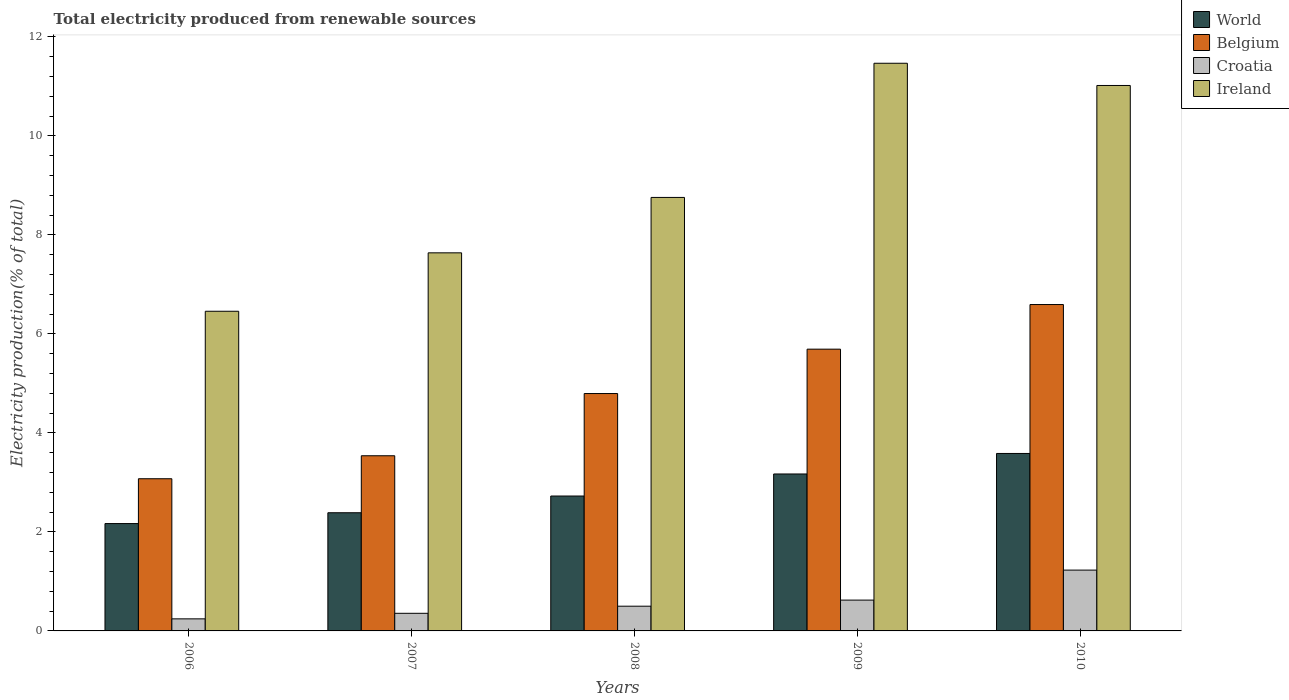How many groups of bars are there?
Your response must be concise. 5. Are the number of bars per tick equal to the number of legend labels?
Provide a short and direct response. Yes. How many bars are there on the 4th tick from the right?
Provide a short and direct response. 4. What is the label of the 2nd group of bars from the left?
Keep it short and to the point. 2007. What is the total electricity produced in Belgium in 2008?
Ensure brevity in your answer.  4.8. Across all years, what is the maximum total electricity produced in Belgium?
Ensure brevity in your answer.  6.59. Across all years, what is the minimum total electricity produced in World?
Your answer should be very brief. 2.17. What is the total total electricity produced in Ireland in the graph?
Your answer should be compact. 45.34. What is the difference between the total electricity produced in Belgium in 2008 and that in 2010?
Your response must be concise. -1.8. What is the difference between the total electricity produced in Belgium in 2008 and the total electricity produced in Ireland in 2006?
Keep it short and to the point. -1.66. What is the average total electricity produced in World per year?
Provide a succinct answer. 2.81. In the year 2009, what is the difference between the total electricity produced in Ireland and total electricity produced in Croatia?
Make the answer very short. 10.84. What is the ratio of the total electricity produced in Ireland in 2007 to that in 2010?
Provide a short and direct response. 0.69. Is the total electricity produced in Croatia in 2006 less than that in 2010?
Provide a short and direct response. Yes. What is the difference between the highest and the second highest total electricity produced in World?
Offer a very short reply. 0.41. What is the difference between the highest and the lowest total electricity produced in Belgium?
Offer a very short reply. 3.52. In how many years, is the total electricity produced in Belgium greater than the average total electricity produced in Belgium taken over all years?
Provide a succinct answer. 3. Is the sum of the total electricity produced in Ireland in 2007 and 2009 greater than the maximum total electricity produced in Belgium across all years?
Your answer should be very brief. Yes. Is it the case that in every year, the sum of the total electricity produced in Ireland and total electricity produced in Belgium is greater than the sum of total electricity produced in Croatia and total electricity produced in World?
Keep it short and to the point. Yes. What does the 1st bar from the right in 2009 represents?
Your answer should be compact. Ireland. How many bars are there?
Provide a succinct answer. 20. Are all the bars in the graph horizontal?
Ensure brevity in your answer.  No. Does the graph contain any zero values?
Provide a short and direct response. No. Does the graph contain grids?
Your response must be concise. No. How many legend labels are there?
Offer a very short reply. 4. How are the legend labels stacked?
Ensure brevity in your answer.  Vertical. What is the title of the graph?
Provide a short and direct response. Total electricity produced from renewable sources. Does "Slovak Republic" appear as one of the legend labels in the graph?
Give a very brief answer. No. What is the label or title of the X-axis?
Keep it short and to the point. Years. What is the Electricity production(% of total) in World in 2006?
Your answer should be compact. 2.17. What is the Electricity production(% of total) in Belgium in 2006?
Make the answer very short. 3.07. What is the Electricity production(% of total) of Croatia in 2006?
Offer a very short reply. 0.24. What is the Electricity production(% of total) in Ireland in 2006?
Make the answer very short. 6.46. What is the Electricity production(% of total) in World in 2007?
Keep it short and to the point. 2.39. What is the Electricity production(% of total) in Belgium in 2007?
Your answer should be compact. 3.54. What is the Electricity production(% of total) in Croatia in 2007?
Offer a terse response. 0.36. What is the Electricity production(% of total) in Ireland in 2007?
Give a very brief answer. 7.64. What is the Electricity production(% of total) of World in 2008?
Your answer should be compact. 2.72. What is the Electricity production(% of total) of Belgium in 2008?
Offer a terse response. 4.8. What is the Electricity production(% of total) in Croatia in 2008?
Provide a succinct answer. 0.5. What is the Electricity production(% of total) in Ireland in 2008?
Provide a short and direct response. 8.76. What is the Electricity production(% of total) of World in 2009?
Your answer should be very brief. 3.17. What is the Electricity production(% of total) in Belgium in 2009?
Provide a succinct answer. 5.69. What is the Electricity production(% of total) of Croatia in 2009?
Your response must be concise. 0.62. What is the Electricity production(% of total) of Ireland in 2009?
Your response must be concise. 11.47. What is the Electricity production(% of total) in World in 2010?
Provide a short and direct response. 3.58. What is the Electricity production(% of total) in Belgium in 2010?
Keep it short and to the point. 6.59. What is the Electricity production(% of total) of Croatia in 2010?
Keep it short and to the point. 1.23. What is the Electricity production(% of total) in Ireland in 2010?
Ensure brevity in your answer.  11.02. Across all years, what is the maximum Electricity production(% of total) of World?
Keep it short and to the point. 3.58. Across all years, what is the maximum Electricity production(% of total) of Belgium?
Offer a terse response. 6.59. Across all years, what is the maximum Electricity production(% of total) in Croatia?
Your response must be concise. 1.23. Across all years, what is the maximum Electricity production(% of total) of Ireland?
Offer a very short reply. 11.47. Across all years, what is the minimum Electricity production(% of total) of World?
Keep it short and to the point. 2.17. Across all years, what is the minimum Electricity production(% of total) of Belgium?
Your answer should be compact. 3.07. Across all years, what is the minimum Electricity production(% of total) of Croatia?
Offer a very short reply. 0.24. Across all years, what is the minimum Electricity production(% of total) in Ireland?
Your response must be concise. 6.46. What is the total Electricity production(% of total) of World in the graph?
Your answer should be very brief. 14.04. What is the total Electricity production(% of total) in Belgium in the graph?
Keep it short and to the point. 23.69. What is the total Electricity production(% of total) in Croatia in the graph?
Make the answer very short. 2.95. What is the total Electricity production(% of total) of Ireland in the graph?
Your answer should be very brief. 45.34. What is the difference between the Electricity production(% of total) in World in 2006 and that in 2007?
Provide a short and direct response. -0.22. What is the difference between the Electricity production(% of total) in Belgium in 2006 and that in 2007?
Keep it short and to the point. -0.46. What is the difference between the Electricity production(% of total) of Croatia in 2006 and that in 2007?
Your answer should be compact. -0.11. What is the difference between the Electricity production(% of total) of Ireland in 2006 and that in 2007?
Your answer should be compact. -1.18. What is the difference between the Electricity production(% of total) in World in 2006 and that in 2008?
Provide a succinct answer. -0.56. What is the difference between the Electricity production(% of total) in Belgium in 2006 and that in 2008?
Provide a short and direct response. -1.72. What is the difference between the Electricity production(% of total) in Croatia in 2006 and that in 2008?
Your response must be concise. -0.26. What is the difference between the Electricity production(% of total) in Ireland in 2006 and that in 2008?
Your response must be concise. -2.3. What is the difference between the Electricity production(% of total) in World in 2006 and that in 2009?
Ensure brevity in your answer.  -1. What is the difference between the Electricity production(% of total) of Belgium in 2006 and that in 2009?
Your response must be concise. -2.62. What is the difference between the Electricity production(% of total) in Croatia in 2006 and that in 2009?
Provide a short and direct response. -0.38. What is the difference between the Electricity production(% of total) in Ireland in 2006 and that in 2009?
Offer a very short reply. -5.01. What is the difference between the Electricity production(% of total) in World in 2006 and that in 2010?
Make the answer very short. -1.42. What is the difference between the Electricity production(% of total) in Belgium in 2006 and that in 2010?
Give a very brief answer. -3.52. What is the difference between the Electricity production(% of total) of Croatia in 2006 and that in 2010?
Ensure brevity in your answer.  -0.98. What is the difference between the Electricity production(% of total) in Ireland in 2006 and that in 2010?
Ensure brevity in your answer.  -4.56. What is the difference between the Electricity production(% of total) of World in 2007 and that in 2008?
Offer a very short reply. -0.34. What is the difference between the Electricity production(% of total) in Belgium in 2007 and that in 2008?
Keep it short and to the point. -1.26. What is the difference between the Electricity production(% of total) of Croatia in 2007 and that in 2008?
Offer a very short reply. -0.14. What is the difference between the Electricity production(% of total) of Ireland in 2007 and that in 2008?
Your response must be concise. -1.12. What is the difference between the Electricity production(% of total) of World in 2007 and that in 2009?
Offer a very short reply. -0.78. What is the difference between the Electricity production(% of total) of Belgium in 2007 and that in 2009?
Your response must be concise. -2.15. What is the difference between the Electricity production(% of total) of Croatia in 2007 and that in 2009?
Your response must be concise. -0.27. What is the difference between the Electricity production(% of total) in Ireland in 2007 and that in 2009?
Offer a very short reply. -3.83. What is the difference between the Electricity production(% of total) in World in 2007 and that in 2010?
Provide a succinct answer. -1.2. What is the difference between the Electricity production(% of total) of Belgium in 2007 and that in 2010?
Your answer should be very brief. -3.05. What is the difference between the Electricity production(% of total) in Croatia in 2007 and that in 2010?
Give a very brief answer. -0.87. What is the difference between the Electricity production(% of total) of Ireland in 2007 and that in 2010?
Provide a succinct answer. -3.38. What is the difference between the Electricity production(% of total) of World in 2008 and that in 2009?
Keep it short and to the point. -0.45. What is the difference between the Electricity production(% of total) in Belgium in 2008 and that in 2009?
Give a very brief answer. -0.9. What is the difference between the Electricity production(% of total) in Croatia in 2008 and that in 2009?
Offer a terse response. -0.12. What is the difference between the Electricity production(% of total) in Ireland in 2008 and that in 2009?
Provide a succinct answer. -2.71. What is the difference between the Electricity production(% of total) in World in 2008 and that in 2010?
Provide a succinct answer. -0.86. What is the difference between the Electricity production(% of total) in Belgium in 2008 and that in 2010?
Your answer should be very brief. -1.8. What is the difference between the Electricity production(% of total) of Croatia in 2008 and that in 2010?
Your response must be concise. -0.73. What is the difference between the Electricity production(% of total) of Ireland in 2008 and that in 2010?
Offer a terse response. -2.26. What is the difference between the Electricity production(% of total) of World in 2009 and that in 2010?
Your response must be concise. -0.41. What is the difference between the Electricity production(% of total) in Belgium in 2009 and that in 2010?
Keep it short and to the point. -0.9. What is the difference between the Electricity production(% of total) in Croatia in 2009 and that in 2010?
Keep it short and to the point. -0.61. What is the difference between the Electricity production(% of total) of Ireland in 2009 and that in 2010?
Offer a terse response. 0.45. What is the difference between the Electricity production(% of total) in World in 2006 and the Electricity production(% of total) in Belgium in 2007?
Your answer should be very brief. -1.37. What is the difference between the Electricity production(% of total) in World in 2006 and the Electricity production(% of total) in Croatia in 2007?
Give a very brief answer. 1.81. What is the difference between the Electricity production(% of total) of World in 2006 and the Electricity production(% of total) of Ireland in 2007?
Keep it short and to the point. -5.47. What is the difference between the Electricity production(% of total) of Belgium in 2006 and the Electricity production(% of total) of Croatia in 2007?
Give a very brief answer. 2.72. What is the difference between the Electricity production(% of total) of Belgium in 2006 and the Electricity production(% of total) of Ireland in 2007?
Your answer should be compact. -4.56. What is the difference between the Electricity production(% of total) in Croatia in 2006 and the Electricity production(% of total) in Ireland in 2007?
Your answer should be very brief. -7.39. What is the difference between the Electricity production(% of total) of World in 2006 and the Electricity production(% of total) of Belgium in 2008?
Give a very brief answer. -2.63. What is the difference between the Electricity production(% of total) of World in 2006 and the Electricity production(% of total) of Croatia in 2008?
Provide a succinct answer. 1.67. What is the difference between the Electricity production(% of total) in World in 2006 and the Electricity production(% of total) in Ireland in 2008?
Give a very brief answer. -6.59. What is the difference between the Electricity production(% of total) in Belgium in 2006 and the Electricity production(% of total) in Croatia in 2008?
Offer a very short reply. 2.57. What is the difference between the Electricity production(% of total) of Belgium in 2006 and the Electricity production(% of total) of Ireland in 2008?
Provide a short and direct response. -5.68. What is the difference between the Electricity production(% of total) of Croatia in 2006 and the Electricity production(% of total) of Ireland in 2008?
Give a very brief answer. -8.51. What is the difference between the Electricity production(% of total) in World in 2006 and the Electricity production(% of total) in Belgium in 2009?
Your response must be concise. -3.52. What is the difference between the Electricity production(% of total) in World in 2006 and the Electricity production(% of total) in Croatia in 2009?
Make the answer very short. 1.55. What is the difference between the Electricity production(% of total) of World in 2006 and the Electricity production(% of total) of Ireland in 2009?
Provide a short and direct response. -9.3. What is the difference between the Electricity production(% of total) of Belgium in 2006 and the Electricity production(% of total) of Croatia in 2009?
Make the answer very short. 2.45. What is the difference between the Electricity production(% of total) in Belgium in 2006 and the Electricity production(% of total) in Ireland in 2009?
Your response must be concise. -8.39. What is the difference between the Electricity production(% of total) of Croatia in 2006 and the Electricity production(% of total) of Ireland in 2009?
Provide a succinct answer. -11.22. What is the difference between the Electricity production(% of total) of World in 2006 and the Electricity production(% of total) of Belgium in 2010?
Offer a terse response. -4.42. What is the difference between the Electricity production(% of total) of World in 2006 and the Electricity production(% of total) of Croatia in 2010?
Provide a short and direct response. 0.94. What is the difference between the Electricity production(% of total) of World in 2006 and the Electricity production(% of total) of Ireland in 2010?
Ensure brevity in your answer.  -8.85. What is the difference between the Electricity production(% of total) of Belgium in 2006 and the Electricity production(% of total) of Croatia in 2010?
Your response must be concise. 1.85. What is the difference between the Electricity production(% of total) of Belgium in 2006 and the Electricity production(% of total) of Ireland in 2010?
Your response must be concise. -7.94. What is the difference between the Electricity production(% of total) in Croatia in 2006 and the Electricity production(% of total) in Ireland in 2010?
Your answer should be compact. -10.77. What is the difference between the Electricity production(% of total) in World in 2007 and the Electricity production(% of total) in Belgium in 2008?
Your answer should be very brief. -2.41. What is the difference between the Electricity production(% of total) in World in 2007 and the Electricity production(% of total) in Croatia in 2008?
Offer a very short reply. 1.89. What is the difference between the Electricity production(% of total) of World in 2007 and the Electricity production(% of total) of Ireland in 2008?
Give a very brief answer. -6.37. What is the difference between the Electricity production(% of total) of Belgium in 2007 and the Electricity production(% of total) of Croatia in 2008?
Your answer should be very brief. 3.04. What is the difference between the Electricity production(% of total) in Belgium in 2007 and the Electricity production(% of total) in Ireland in 2008?
Offer a very short reply. -5.22. What is the difference between the Electricity production(% of total) of Croatia in 2007 and the Electricity production(% of total) of Ireland in 2008?
Ensure brevity in your answer.  -8.4. What is the difference between the Electricity production(% of total) in World in 2007 and the Electricity production(% of total) in Belgium in 2009?
Your response must be concise. -3.3. What is the difference between the Electricity production(% of total) in World in 2007 and the Electricity production(% of total) in Croatia in 2009?
Offer a very short reply. 1.76. What is the difference between the Electricity production(% of total) in World in 2007 and the Electricity production(% of total) in Ireland in 2009?
Provide a succinct answer. -9.08. What is the difference between the Electricity production(% of total) of Belgium in 2007 and the Electricity production(% of total) of Croatia in 2009?
Offer a very short reply. 2.92. What is the difference between the Electricity production(% of total) in Belgium in 2007 and the Electricity production(% of total) in Ireland in 2009?
Ensure brevity in your answer.  -7.93. What is the difference between the Electricity production(% of total) in Croatia in 2007 and the Electricity production(% of total) in Ireland in 2009?
Offer a very short reply. -11.11. What is the difference between the Electricity production(% of total) of World in 2007 and the Electricity production(% of total) of Belgium in 2010?
Provide a succinct answer. -4.21. What is the difference between the Electricity production(% of total) of World in 2007 and the Electricity production(% of total) of Croatia in 2010?
Ensure brevity in your answer.  1.16. What is the difference between the Electricity production(% of total) of World in 2007 and the Electricity production(% of total) of Ireland in 2010?
Your response must be concise. -8.63. What is the difference between the Electricity production(% of total) of Belgium in 2007 and the Electricity production(% of total) of Croatia in 2010?
Ensure brevity in your answer.  2.31. What is the difference between the Electricity production(% of total) in Belgium in 2007 and the Electricity production(% of total) in Ireland in 2010?
Ensure brevity in your answer.  -7.48. What is the difference between the Electricity production(% of total) of Croatia in 2007 and the Electricity production(% of total) of Ireland in 2010?
Provide a short and direct response. -10.66. What is the difference between the Electricity production(% of total) in World in 2008 and the Electricity production(% of total) in Belgium in 2009?
Offer a very short reply. -2.97. What is the difference between the Electricity production(% of total) in World in 2008 and the Electricity production(% of total) in Croatia in 2009?
Give a very brief answer. 2.1. What is the difference between the Electricity production(% of total) of World in 2008 and the Electricity production(% of total) of Ireland in 2009?
Keep it short and to the point. -8.74. What is the difference between the Electricity production(% of total) of Belgium in 2008 and the Electricity production(% of total) of Croatia in 2009?
Provide a short and direct response. 4.17. What is the difference between the Electricity production(% of total) in Belgium in 2008 and the Electricity production(% of total) in Ireland in 2009?
Your answer should be compact. -6.67. What is the difference between the Electricity production(% of total) in Croatia in 2008 and the Electricity production(% of total) in Ireland in 2009?
Provide a succinct answer. -10.97. What is the difference between the Electricity production(% of total) in World in 2008 and the Electricity production(% of total) in Belgium in 2010?
Your answer should be compact. -3.87. What is the difference between the Electricity production(% of total) in World in 2008 and the Electricity production(% of total) in Croatia in 2010?
Your response must be concise. 1.5. What is the difference between the Electricity production(% of total) in World in 2008 and the Electricity production(% of total) in Ireland in 2010?
Your answer should be very brief. -8.29. What is the difference between the Electricity production(% of total) in Belgium in 2008 and the Electricity production(% of total) in Croatia in 2010?
Your answer should be compact. 3.57. What is the difference between the Electricity production(% of total) of Belgium in 2008 and the Electricity production(% of total) of Ireland in 2010?
Provide a short and direct response. -6.22. What is the difference between the Electricity production(% of total) in Croatia in 2008 and the Electricity production(% of total) in Ireland in 2010?
Keep it short and to the point. -10.52. What is the difference between the Electricity production(% of total) in World in 2009 and the Electricity production(% of total) in Belgium in 2010?
Your answer should be compact. -3.42. What is the difference between the Electricity production(% of total) in World in 2009 and the Electricity production(% of total) in Croatia in 2010?
Keep it short and to the point. 1.94. What is the difference between the Electricity production(% of total) of World in 2009 and the Electricity production(% of total) of Ireland in 2010?
Your response must be concise. -7.85. What is the difference between the Electricity production(% of total) of Belgium in 2009 and the Electricity production(% of total) of Croatia in 2010?
Give a very brief answer. 4.46. What is the difference between the Electricity production(% of total) of Belgium in 2009 and the Electricity production(% of total) of Ireland in 2010?
Offer a terse response. -5.33. What is the difference between the Electricity production(% of total) of Croatia in 2009 and the Electricity production(% of total) of Ireland in 2010?
Keep it short and to the point. -10.4. What is the average Electricity production(% of total) of World per year?
Offer a very short reply. 2.81. What is the average Electricity production(% of total) in Belgium per year?
Provide a succinct answer. 4.74. What is the average Electricity production(% of total) in Croatia per year?
Make the answer very short. 0.59. What is the average Electricity production(% of total) in Ireland per year?
Give a very brief answer. 9.07. In the year 2006, what is the difference between the Electricity production(% of total) of World and Electricity production(% of total) of Belgium?
Give a very brief answer. -0.91. In the year 2006, what is the difference between the Electricity production(% of total) of World and Electricity production(% of total) of Croatia?
Your answer should be compact. 1.92. In the year 2006, what is the difference between the Electricity production(% of total) of World and Electricity production(% of total) of Ireland?
Give a very brief answer. -4.29. In the year 2006, what is the difference between the Electricity production(% of total) of Belgium and Electricity production(% of total) of Croatia?
Your answer should be compact. 2.83. In the year 2006, what is the difference between the Electricity production(% of total) of Belgium and Electricity production(% of total) of Ireland?
Your response must be concise. -3.38. In the year 2006, what is the difference between the Electricity production(% of total) in Croatia and Electricity production(% of total) in Ireland?
Provide a succinct answer. -6.21. In the year 2007, what is the difference between the Electricity production(% of total) of World and Electricity production(% of total) of Belgium?
Keep it short and to the point. -1.15. In the year 2007, what is the difference between the Electricity production(% of total) in World and Electricity production(% of total) in Croatia?
Make the answer very short. 2.03. In the year 2007, what is the difference between the Electricity production(% of total) in World and Electricity production(% of total) in Ireland?
Make the answer very short. -5.25. In the year 2007, what is the difference between the Electricity production(% of total) in Belgium and Electricity production(% of total) in Croatia?
Your answer should be very brief. 3.18. In the year 2007, what is the difference between the Electricity production(% of total) in Belgium and Electricity production(% of total) in Ireland?
Your answer should be very brief. -4.1. In the year 2007, what is the difference between the Electricity production(% of total) of Croatia and Electricity production(% of total) of Ireland?
Offer a very short reply. -7.28. In the year 2008, what is the difference between the Electricity production(% of total) of World and Electricity production(% of total) of Belgium?
Ensure brevity in your answer.  -2.07. In the year 2008, what is the difference between the Electricity production(% of total) in World and Electricity production(% of total) in Croatia?
Keep it short and to the point. 2.23. In the year 2008, what is the difference between the Electricity production(% of total) of World and Electricity production(% of total) of Ireland?
Offer a very short reply. -6.03. In the year 2008, what is the difference between the Electricity production(% of total) in Belgium and Electricity production(% of total) in Croatia?
Give a very brief answer. 4.3. In the year 2008, what is the difference between the Electricity production(% of total) in Belgium and Electricity production(% of total) in Ireland?
Provide a succinct answer. -3.96. In the year 2008, what is the difference between the Electricity production(% of total) in Croatia and Electricity production(% of total) in Ireland?
Offer a very short reply. -8.26. In the year 2009, what is the difference between the Electricity production(% of total) in World and Electricity production(% of total) in Belgium?
Give a very brief answer. -2.52. In the year 2009, what is the difference between the Electricity production(% of total) of World and Electricity production(% of total) of Croatia?
Your response must be concise. 2.55. In the year 2009, what is the difference between the Electricity production(% of total) of World and Electricity production(% of total) of Ireland?
Offer a terse response. -8.3. In the year 2009, what is the difference between the Electricity production(% of total) in Belgium and Electricity production(% of total) in Croatia?
Provide a short and direct response. 5.07. In the year 2009, what is the difference between the Electricity production(% of total) in Belgium and Electricity production(% of total) in Ireland?
Give a very brief answer. -5.78. In the year 2009, what is the difference between the Electricity production(% of total) of Croatia and Electricity production(% of total) of Ireland?
Your answer should be compact. -10.84. In the year 2010, what is the difference between the Electricity production(% of total) of World and Electricity production(% of total) of Belgium?
Your answer should be very brief. -3.01. In the year 2010, what is the difference between the Electricity production(% of total) of World and Electricity production(% of total) of Croatia?
Ensure brevity in your answer.  2.36. In the year 2010, what is the difference between the Electricity production(% of total) in World and Electricity production(% of total) in Ireland?
Offer a terse response. -7.43. In the year 2010, what is the difference between the Electricity production(% of total) in Belgium and Electricity production(% of total) in Croatia?
Offer a terse response. 5.36. In the year 2010, what is the difference between the Electricity production(% of total) in Belgium and Electricity production(% of total) in Ireland?
Keep it short and to the point. -4.43. In the year 2010, what is the difference between the Electricity production(% of total) in Croatia and Electricity production(% of total) in Ireland?
Provide a short and direct response. -9.79. What is the ratio of the Electricity production(% of total) of World in 2006 to that in 2007?
Keep it short and to the point. 0.91. What is the ratio of the Electricity production(% of total) of Belgium in 2006 to that in 2007?
Give a very brief answer. 0.87. What is the ratio of the Electricity production(% of total) of Croatia in 2006 to that in 2007?
Provide a short and direct response. 0.68. What is the ratio of the Electricity production(% of total) of Ireland in 2006 to that in 2007?
Keep it short and to the point. 0.85. What is the ratio of the Electricity production(% of total) in World in 2006 to that in 2008?
Your answer should be compact. 0.8. What is the ratio of the Electricity production(% of total) in Belgium in 2006 to that in 2008?
Offer a very short reply. 0.64. What is the ratio of the Electricity production(% of total) of Croatia in 2006 to that in 2008?
Give a very brief answer. 0.49. What is the ratio of the Electricity production(% of total) of Ireland in 2006 to that in 2008?
Your answer should be very brief. 0.74. What is the ratio of the Electricity production(% of total) in World in 2006 to that in 2009?
Provide a succinct answer. 0.68. What is the ratio of the Electricity production(% of total) in Belgium in 2006 to that in 2009?
Provide a short and direct response. 0.54. What is the ratio of the Electricity production(% of total) of Croatia in 2006 to that in 2009?
Make the answer very short. 0.39. What is the ratio of the Electricity production(% of total) in Ireland in 2006 to that in 2009?
Provide a succinct answer. 0.56. What is the ratio of the Electricity production(% of total) of World in 2006 to that in 2010?
Offer a terse response. 0.6. What is the ratio of the Electricity production(% of total) of Belgium in 2006 to that in 2010?
Offer a terse response. 0.47. What is the ratio of the Electricity production(% of total) in Croatia in 2006 to that in 2010?
Your answer should be compact. 0.2. What is the ratio of the Electricity production(% of total) in Ireland in 2006 to that in 2010?
Offer a terse response. 0.59. What is the ratio of the Electricity production(% of total) of World in 2007 to that in 2008?
Your response must be concise. 0.88. What is the ratio of the Electricity production(% of total) of Belgium in 2007 to that in 2008?
Your answer should be very brief. 0.74. What is the ratio of the Electricity production(% of total) of Croatia in 2007 to that in 2008?
Your response must be concise. 0.71. What is the ratio of the Electricity production(% of total) of Ireland in 2007 to that in 2008?
Make the answer very short. 0.87. What is the ratio of the Electricity production(% of total) of World in 2007 to that in 2009?
Your answer should be very brief. 0.75. What is the ratio of the Electricity production(% of total) of Belgium in 2007 to that in 2009?
Offer a very short reply. 0.62. What is the ratio of the Electricity production(% of total) of Croatia in 2007 to that in 2009?
Your answer should be very brief. 0.57. What is the ratio of the Electricity production(% of total) in Ireland in 2007 to that in 2009?
Provide a succinct answer. 0.67. What is the ratio of the Electricity production(% of total) in World in 2007 to that in 2010?
Offer a very short reply. 0.67. What is the ratio of the Electricity production(% of total) in Belgium in 2007 to that in 2010?
Make the answer very short. 0.54. What is the ratio of the Electricity production(% of total) of Croatia in 2007 to that in 2010?
Offer a very short reply. 0.29. What is the ratio of the Electricity production(% of total) of Ireland in 2007 to that in 2010?
Offer a very short reply. 0.69. What is the ratio of the Electricity production(% of total) in World in 2008 to that in 2009?
Keep it short and to the point. 0.86. What is the ratio of the Electricity production(% of total) of Belgium in 2008 to that in 2009?
Your answer should be very brief. 0.84. What is the ratio of the Electricity production(% of total) of Croatia in 2008 to that in 2009?
Offer a terse response. 0.8. What is the ratio of the Electricity production(% of total) in Ireland in 2008 to that in 2009?
Give a very brief answer. 0.76. What is the ratio of the Electricity production(% of total) of World in 2008 to that in 2010?
Give a very brief answer. 0.76. What is the ratio of the Electricity production(% of total) in Belgium in 2008 to that in 2010?
Ensure brevity in your answer.  0.73. What is the ratio of the Electricity production(% of total) of Croatia in 2008 to that in 2010?
Ensure brevity in your answer.  0.41. What is the ratio of the Electricity production(% of total) in Ireland in 2008 to that in 2010?
Offer a very short reply. 0.79. What is the ratio of the Electricity production(% of total) in World in 2009 to that in 2010?
Provide a short and direct response. 0.88. What is the ratio of the Electricity production(% of total) in Belgium in 2009 to that in 2010?
Keep it short and to the point. 0.86. What is the ratio of the Electricity production(% of total) of Croatia in 2009 to that in 2010?
Provide a succinct answer. 0.51. What is the ratio of the Electricity production(% of total) in Ireland in 2009 to that in 2010?
Provide a succinct answer. 1.04. What is the difference between the highest and the second highest Electricity production(% of total) of World?
Give a very brief answer. 0.41. What is the difference between the highest and the second highest Electricity production(% of total) in Belgium?
Ensure brevity in your answer.  0.9. What is the difference between the highest and the second highest Electricity production(% of total) in Croatia?
Offer a very short reply. 0.61. What is the difference between the highest and the second highest Electricity production(% of total) in Ireland?
Give a very brief answer. 0.45. What is the difference between the highest and the lowest Electricity production(% of total) in World?
Offer a very short reply. 1.42. What is the difference between the highest and the lowest Electricity production(% of total) in Belgium?
Keep it short and to the point. 3.52. What is the difference between the highest and the lowest Electricity production(% of total) of Croatia?
Your answer should be very brief. 0.98. What is the difference between the highest and the lowest Electricity production(% of total) of Ireland?
Provide a succinct answer. 5.01. 